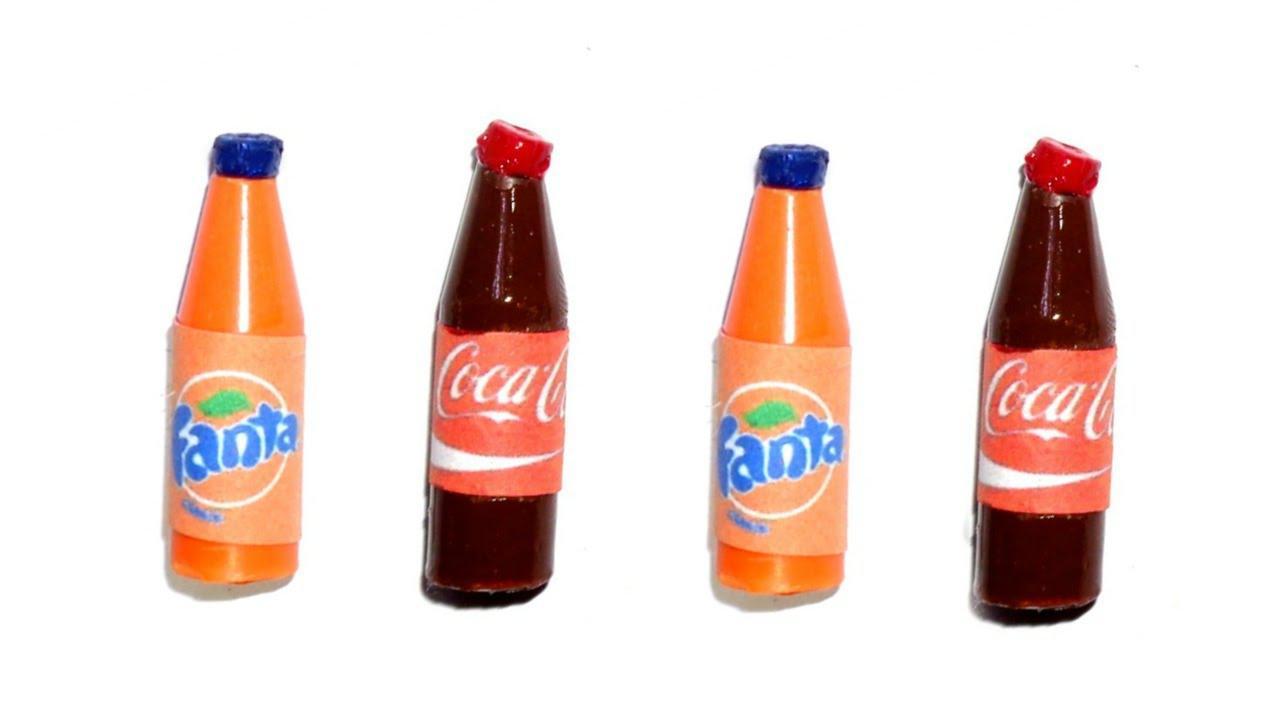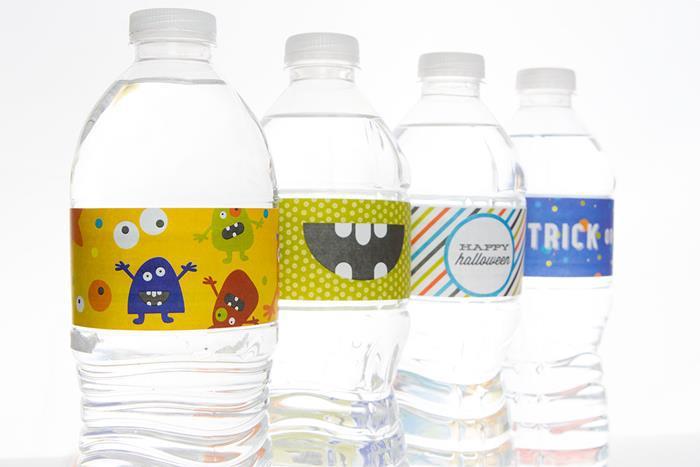The first image is the image on the left, the second image is the image on the right. Examine the images to the left and right. Is the description "The left image contains at least three cans of soda." accurate? Answer yes or no. No. 